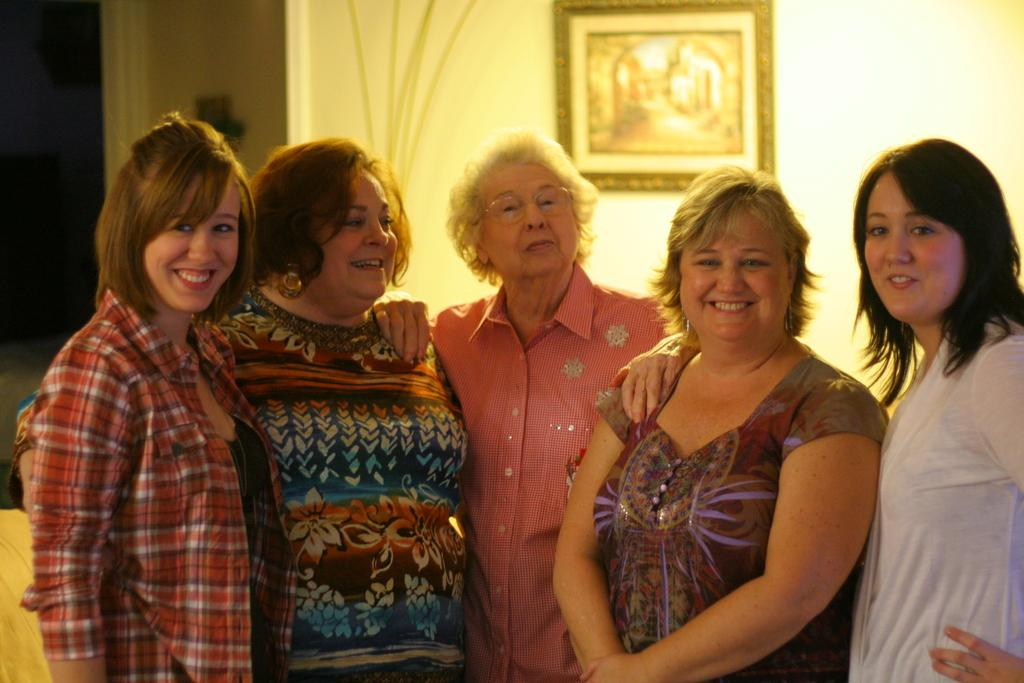How many women are in the image? There are five women in the image. What are the women doing in the image? The women are standing in the image. What can be observed about the women's attire? The women are wearing clothes in the image. What expressions do the women have on their faces? The women are smiling in the image. What type of accessory can be seen on some of the women? Some of the women are wearing earrings in the image. What is present on the wall behind the women? There is a frame on the wall behind the women in the image. How are the women sorting the pests in the image? There are no pests present in the image, and the women are not sorting anything. What type of battle is depicted in the image? There is no battle depicted in the image; it features five women standing and smiling. 